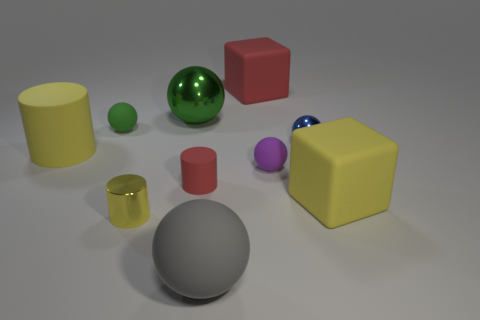What material is the red object to the left of the large thing that is in front of the large yellow block?
Make the answer very short. Rubber. What number of big rubber things have the same shape as the small yellow metallic object?
Offer a very short reply. 1. What is the shape of the gray thing?
Give a very brief answer. Sphere. Are there fewer shiny spheres than metal things?
Ensure brevity in your answer.  Yes. What is the material of the small green object that is the same shape as the tiny purple matte thing?
Ensure brevity in your answer.  Rubber. Are there more small red cylinders than large red metal things?
Offer a terse response. Yes. How many other objects are there of the same color as the tiny matte cylinder?
Offer a terse response. 1. Does the tiny green ball have the same material as the large sphere behind the gray object?
Give a very brief answer. No. There is a large matte block in front of the rubber cube behind the large yellow cylinder; what number of small purple things are to the left of it?
Make the answer very short. 1. Are there fewer red rubber things that are in front of the small blue thing than yellow things to the left of the small purple rubber ball?
Provide a succinct answer. Yes. 